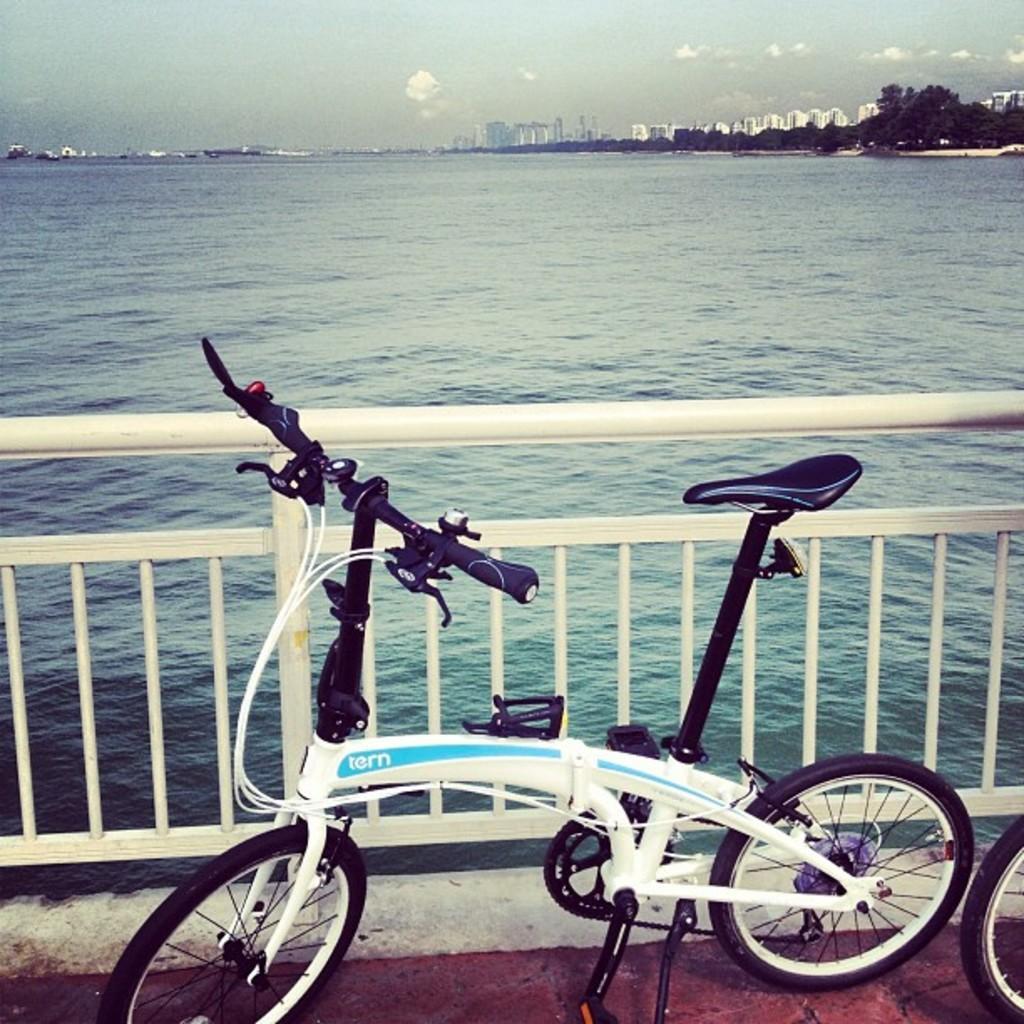Please provide a concise description of this image. In this image there is the sky towards the top of the image, there are clouds in the sky, there are buildings, there are trees towards the right of the image, there is sea, there is fencing, there are bicycles. 